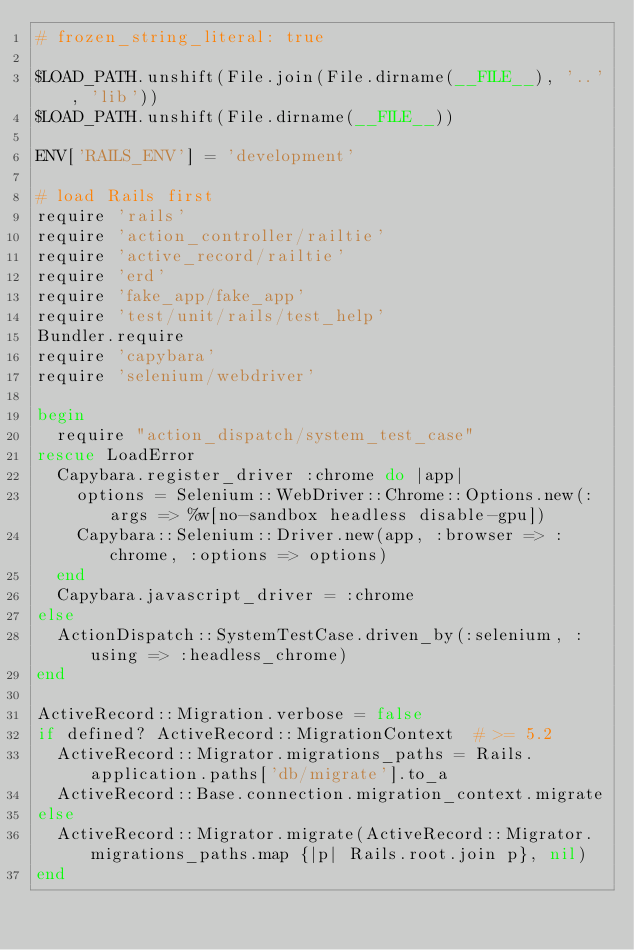Convert code to text. <code><loc_0><loc_0><loc_500><loc_500><_Ruby_># frozen_string_literal: true

$LOAD_PATH.unshift(File.join(File.dirname(__FILE__), '..', 'lib'))
$LOAD_PATH.unshift(File.dirname(__FILE__))

ENV['RAILS_ENV'] = 'development'

# load Rails first
require 'rails'
require 'action_controller/railtie'
require 'active_record/railtie'
require 'erd'
require 'fake_app/fake_app'
require 'test/unit/rails/test_help'
Bundler.require
require 'capybara'
require 'selenium/webdriver'

begin
  require "action_dispatch/system_test_case"
rescue LoadError
  Capybara.register_driver :chrome do |app|
    options = Selenium::WebDriver::Chrome::Options.new(:args => %w[no-sandbox headless disable-gpu])
    Capybara::Selenium::Driver.new(app, :browser => :chrome, :options => options)
  end
  Capybara.javascript_driver = :chrome
else
  ActionDispatch::SystemTestCase.driven_by(:selenium, :using => :headless_chrome)
end

ActiveRecord::Migration.verbose = false
if defined? ActiveRecord::MigrationContext  # >= 5.2
  ActiveRecord::Migrator.migrations_paths = Rails.application.paths['db/migrate'].to_a
  ActiveRecord::Base.connection.migration_context.migrate
else
  ActiveRecord::Migrator.migrate(ActiveRecord::Migrator.migrations_paths.map {|p| Rails.root.join p}, nil)
end
</code> 